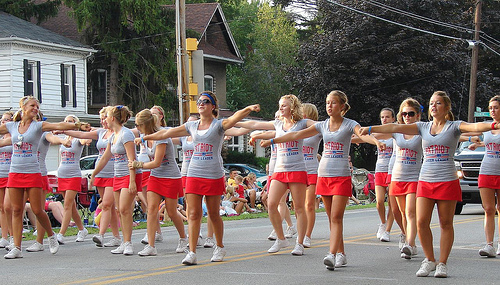<image>
Can you confirm if the shirt is to the right of the girl? No. The shirt is not to the right of the girl. The horizontal positioning shows a different relationship. Where is the truck in relation to the woman? Is it in front of the woman? No. The truck is not in front of the woman. The spatial positioning shows a different relationship between these objects. 